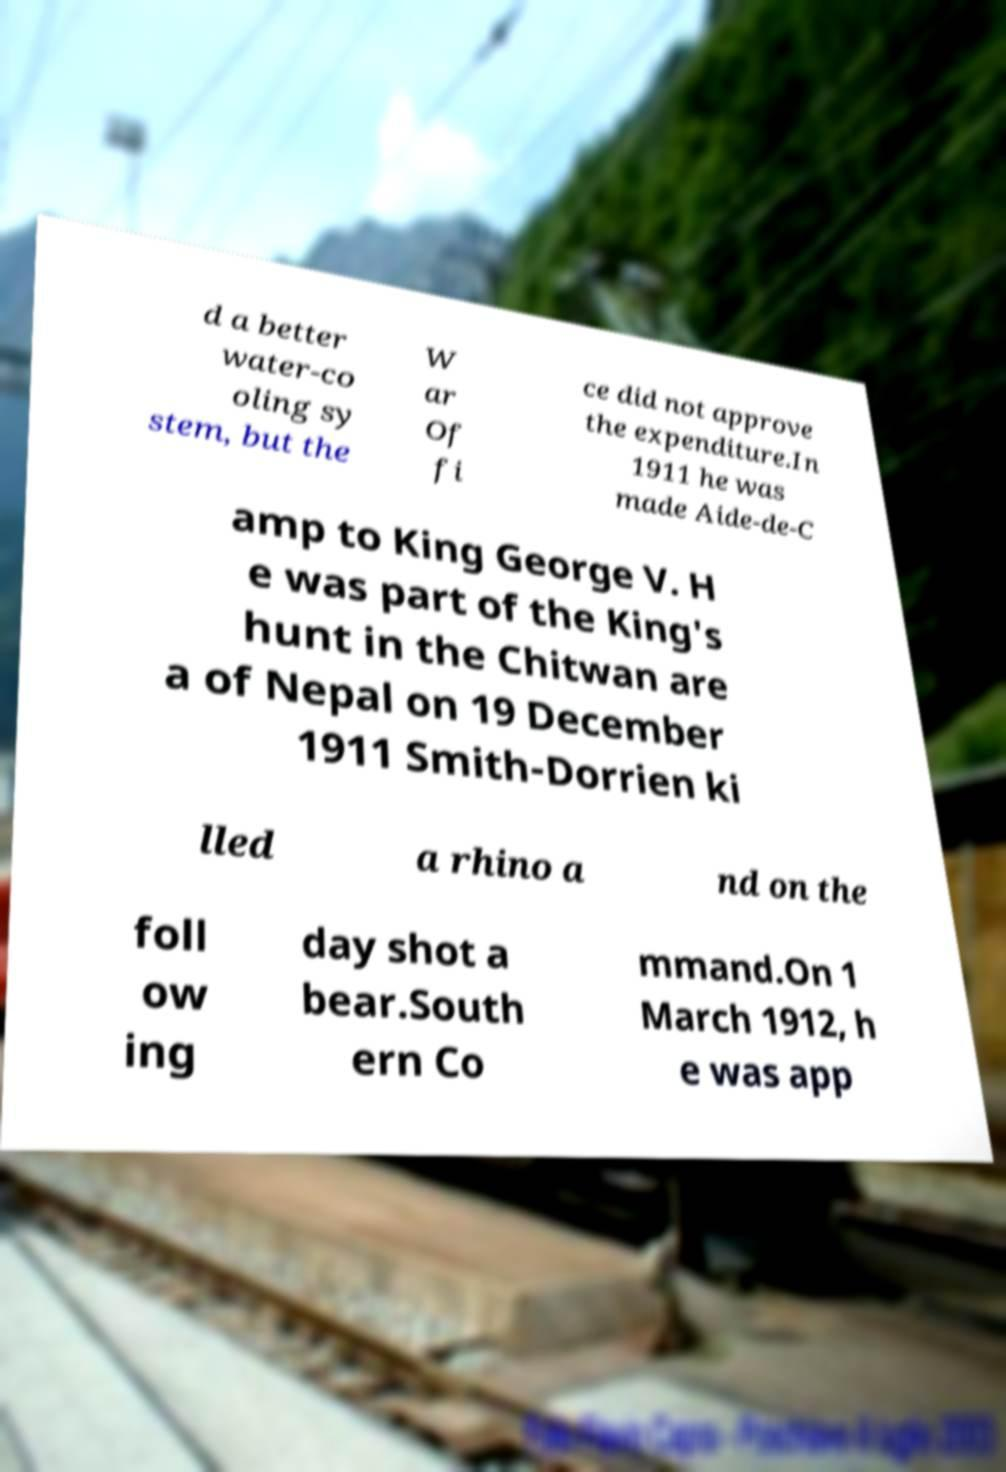What messages or text are displayed in this image? I need them in a readable, typed format. d a better water-co oling sy stem, but the W ar Of fi ce did not approve the expenditure.In 1911 he was made Aide-de-C amp to King George V. H e was part of the King's hunt in the Chitwan are a of Nepal on 19 December 1911 Smith-Dorrien ki lled a rhino a nd on the foll ow ing day shot a bear.South ern Co mmand.On 1 March 1912, h e was app 